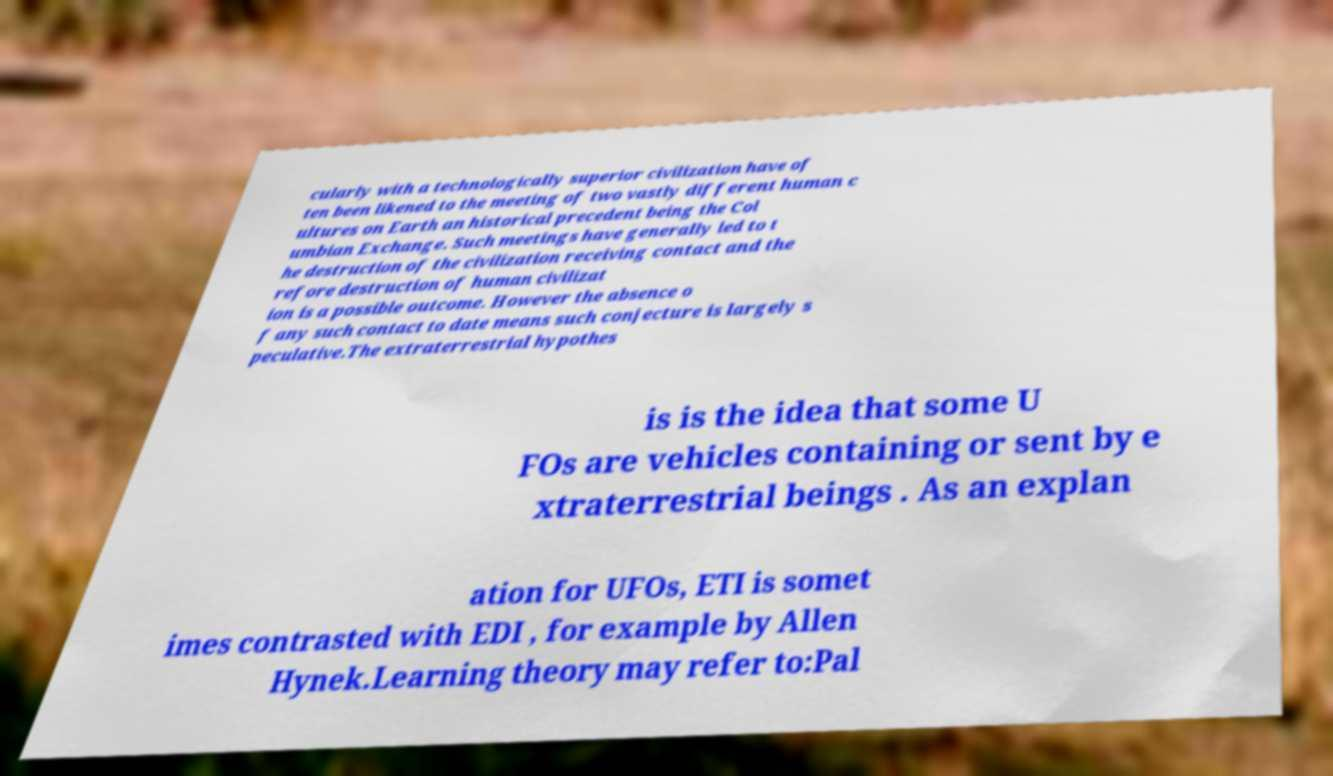Could you assist in decoding the text presented in this image and type it out clearly? cularly with a technologically superior civilization have of ten been likened to the meeting of two vastly different human c ultures on Earth an historical precedent being the Col umbian Exchange. Such meetings have generally led to t he destruction of the civilization receiving contact and the refore destruction of human civilizat ion is a possible outcome. However the absence o f any such contact to date means such conjecture is largely s peculative.The extraterrestrial hypothes is is the idea that some U FOs are vehicles containing or sent by e xtraterrestrial beings . As an explan ation for UFOs, ETI is somet imes contrasted with EDI , for example by Allen Hynek.Learning theory may refer to:Pal 